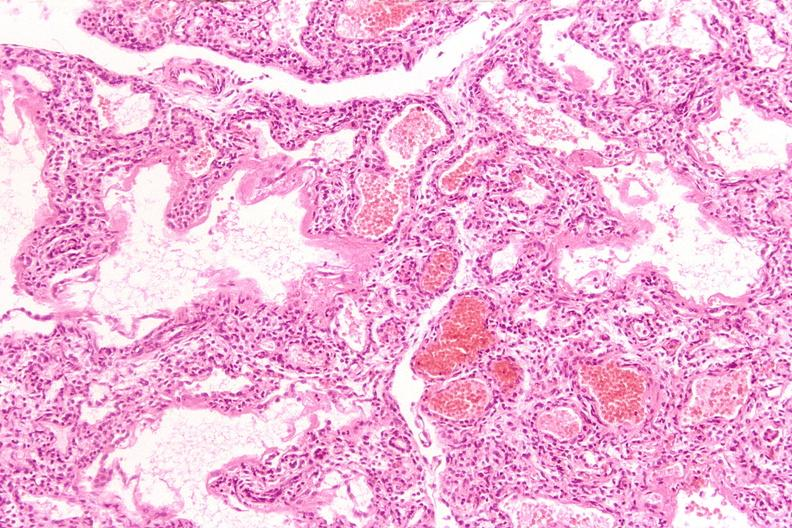s respiratory present?
Answer the question using a single word or phrase. Yes 